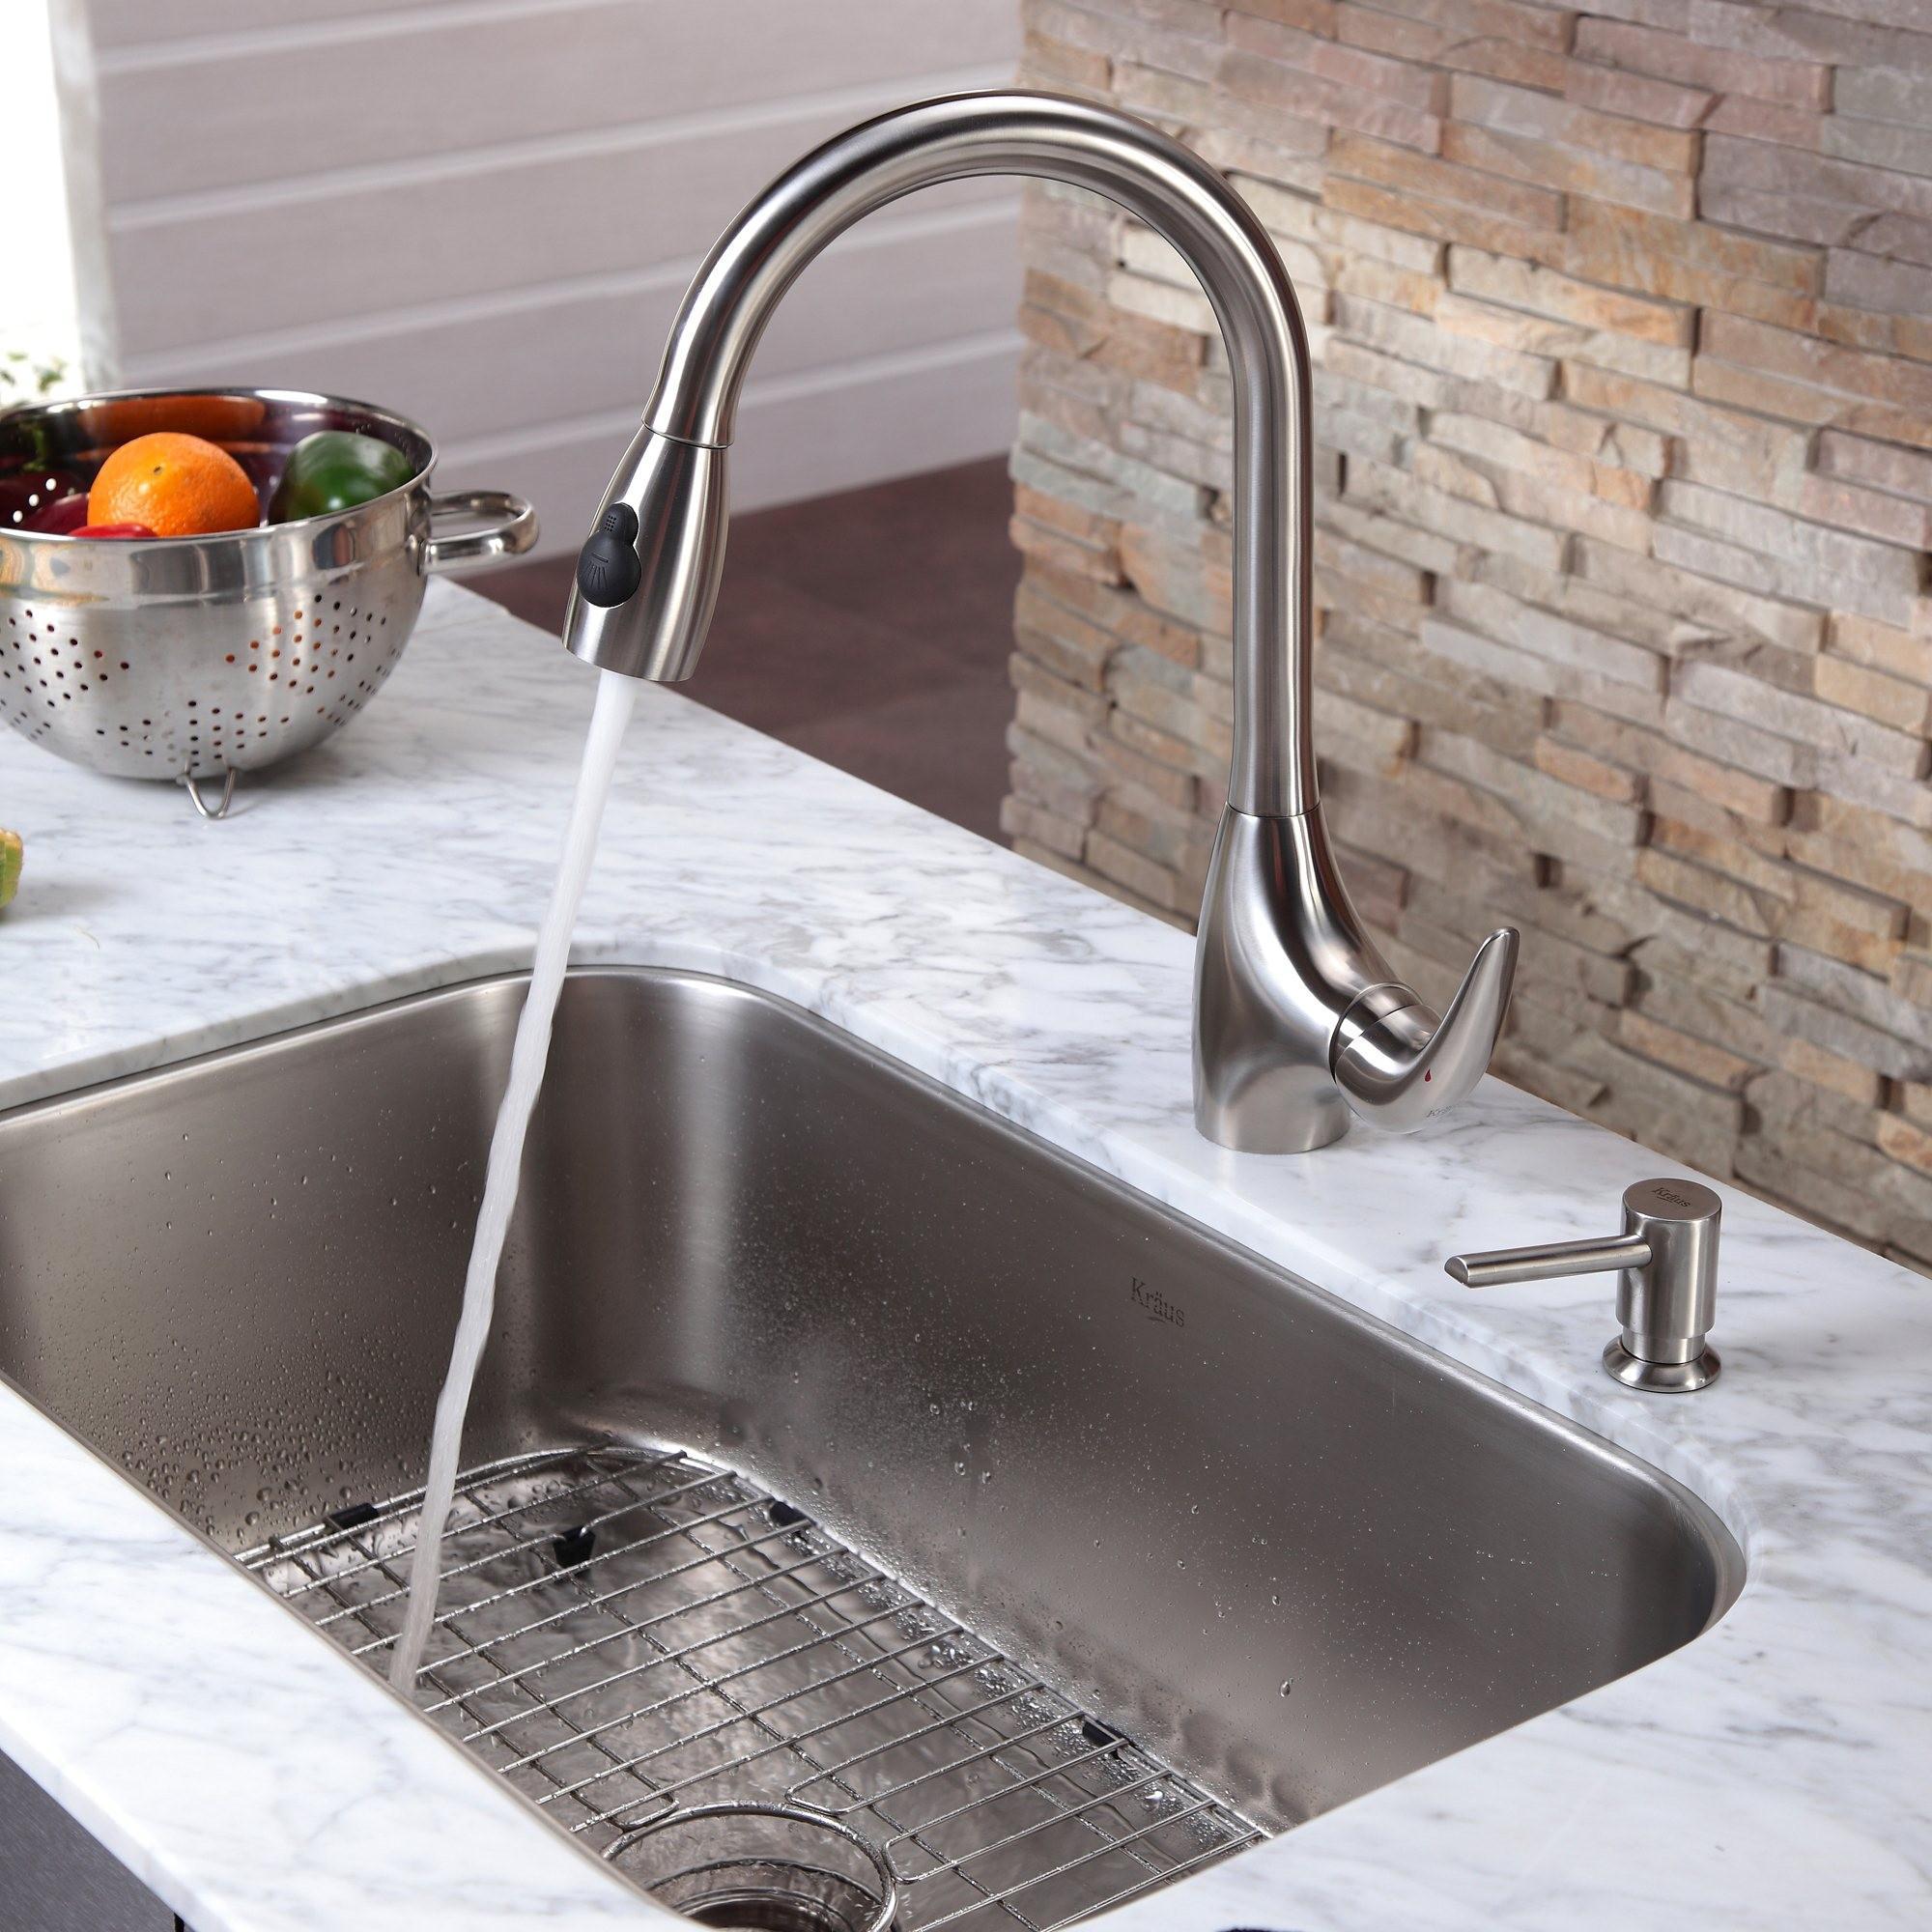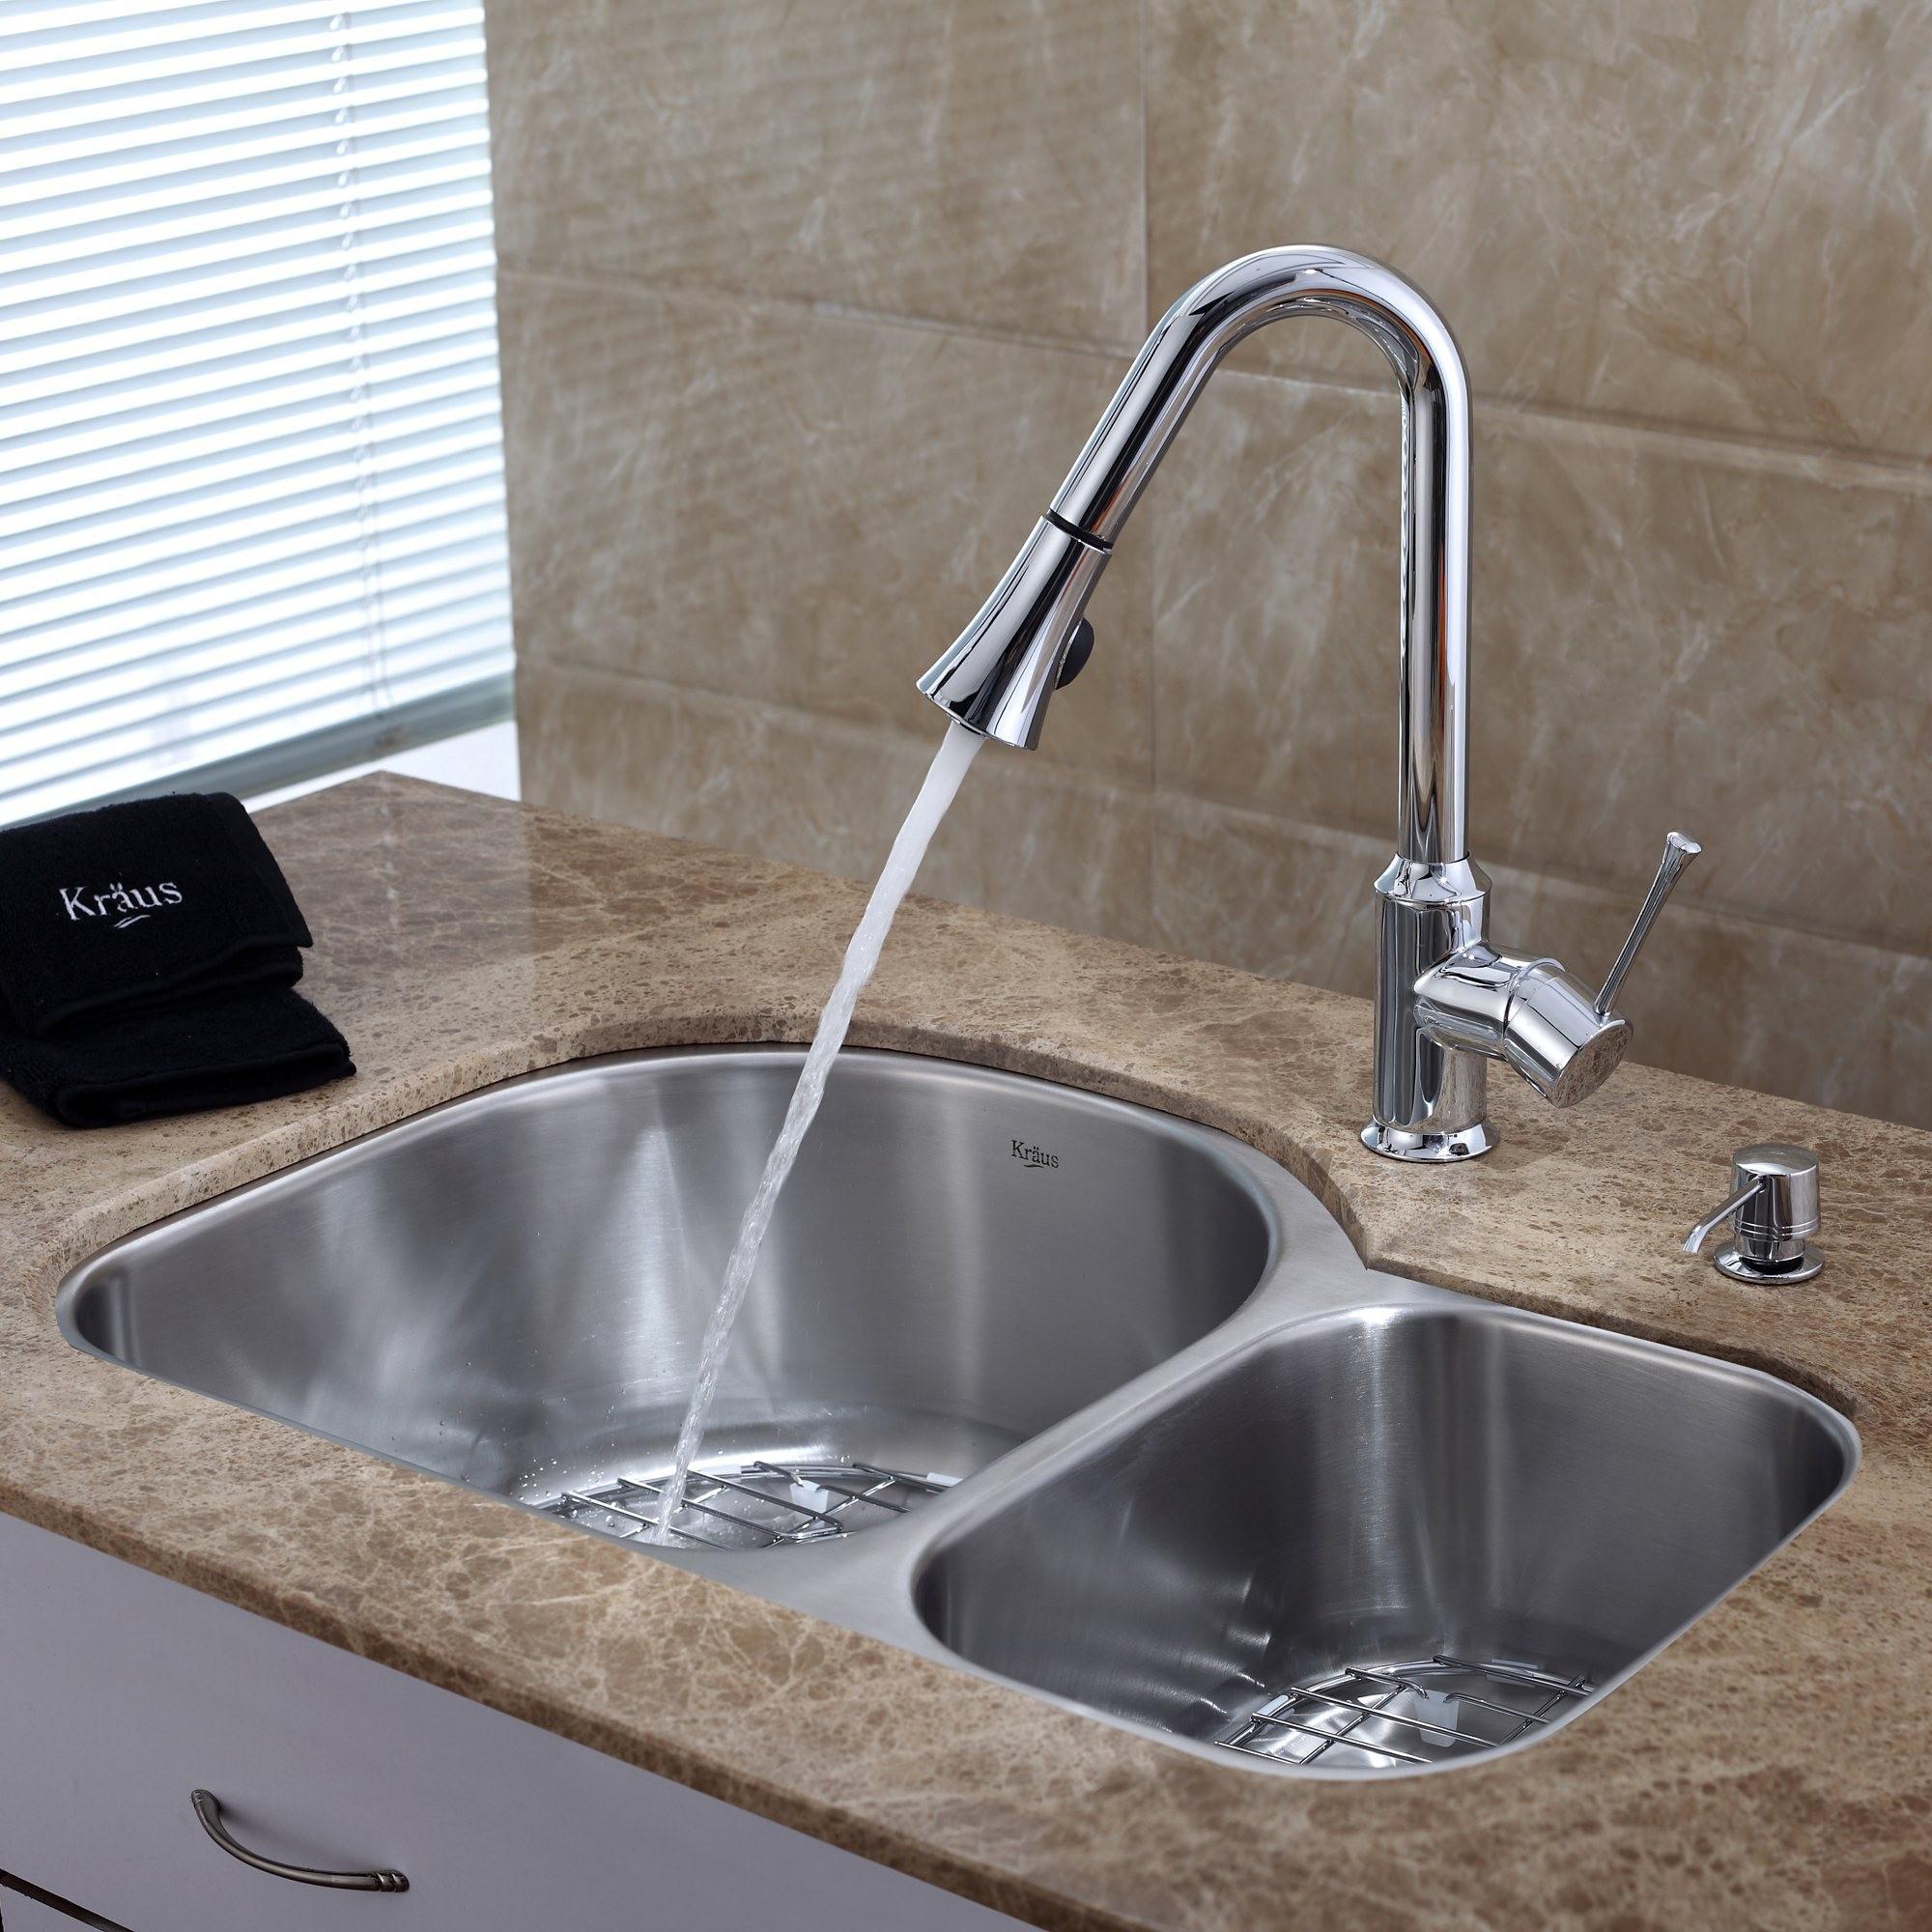The first image is the image on the left, the second image is the image on the right. Analyze the images presented: Is the assertion "An image shows a single-basin steel sink with a wire rack insert, inset in a gray swirl marble counter." valid? Answer yes or no. Yes. The first image is the image on the left, the second image is the image on the right. Evaluate the accuracy of this statement regarding the images: "The sink in the image on the right has a double basin.". Is it true? Answer yes or no. Yes. 